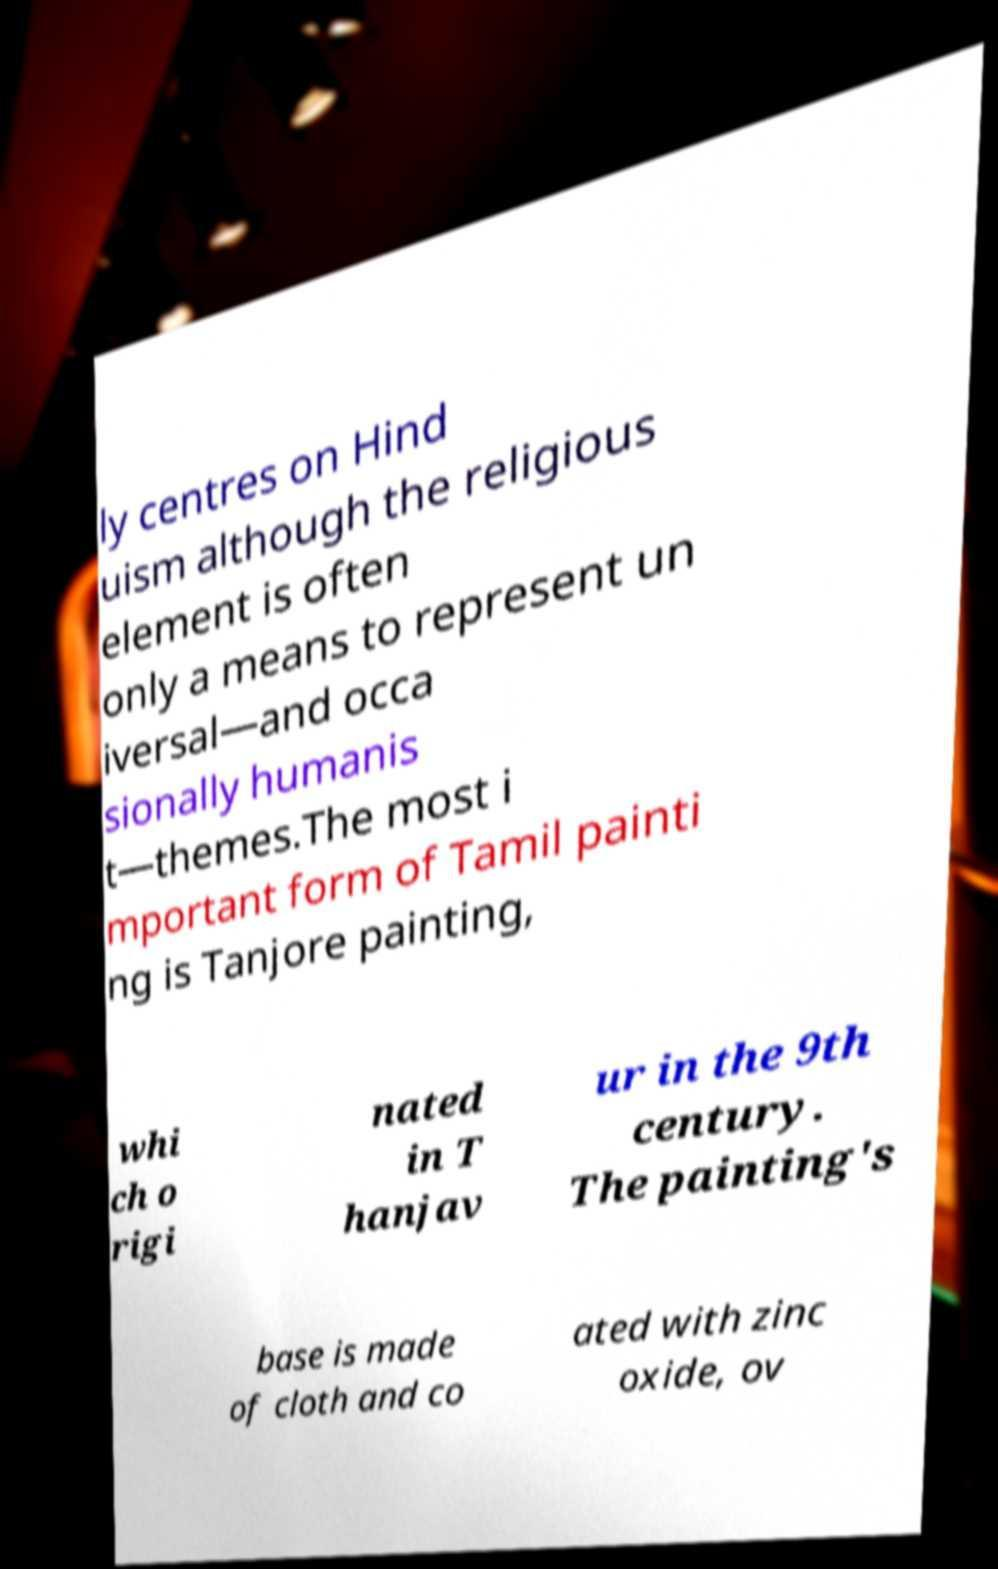Could you extract and type out the text from this image? ly centres on Hind uism although the religious element is often only a means to represent un iversal—and occa sionally humanis t—themes.The most i mportant form of Tamil painti ng is Tanjore painting, whi ch o rigi nated in T hanjav ur in the 9th century. The painting's base is made of cloth and co ated with zinc oxide, ov 